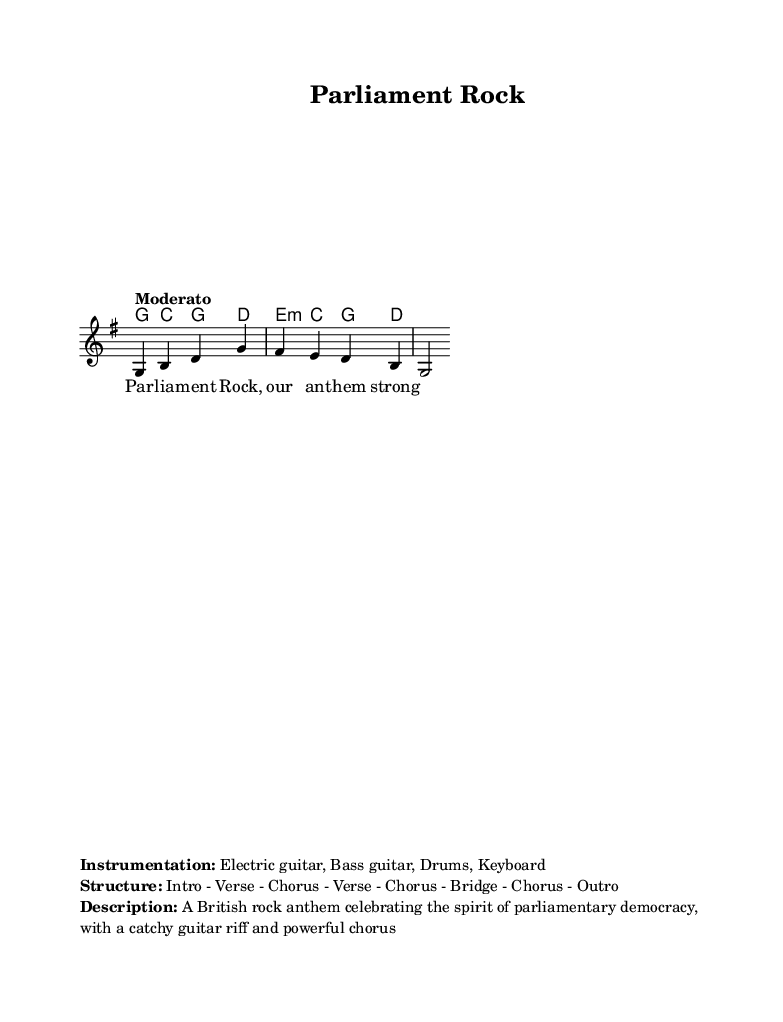What is the key signature of this music? The key signature is G major, indicated by the presence of one sharp (F#) in the staff notation.
Answer: G major What is the time signature of this music? The time signature is 4/4, which is shown at the beginning of the score, indicating that there are four beats per measure.
Answer: 4/4 What is the tempo marking for this music? The tempo marking is "Moderato," a term typically referring to a moderate speed, and it is directly stated at the beginning of the score.
Answer: Moderato What instruments are included in the instrumentation? The instrumentation listed states Electric guitar, Bass guitar, Drums, Keyboard, which are used in the arrangement of the piece.
Answer: Electric guitar, Bass guitar, Drums, Keyboard How many sections are in the structure of the song? The structure given outlines eight sections: Intro, Verse, Chorus, Verse, Chorus, Bridge, Chorus, and Outro, making a total of eight parts.
Answer: Eight What is the overall theme of the song? The description notes that the song celebrates the spirit of parliamentary democracy, highlighting its essence as a rock anthem.
Answer: Spirit of parliamentary democracy 